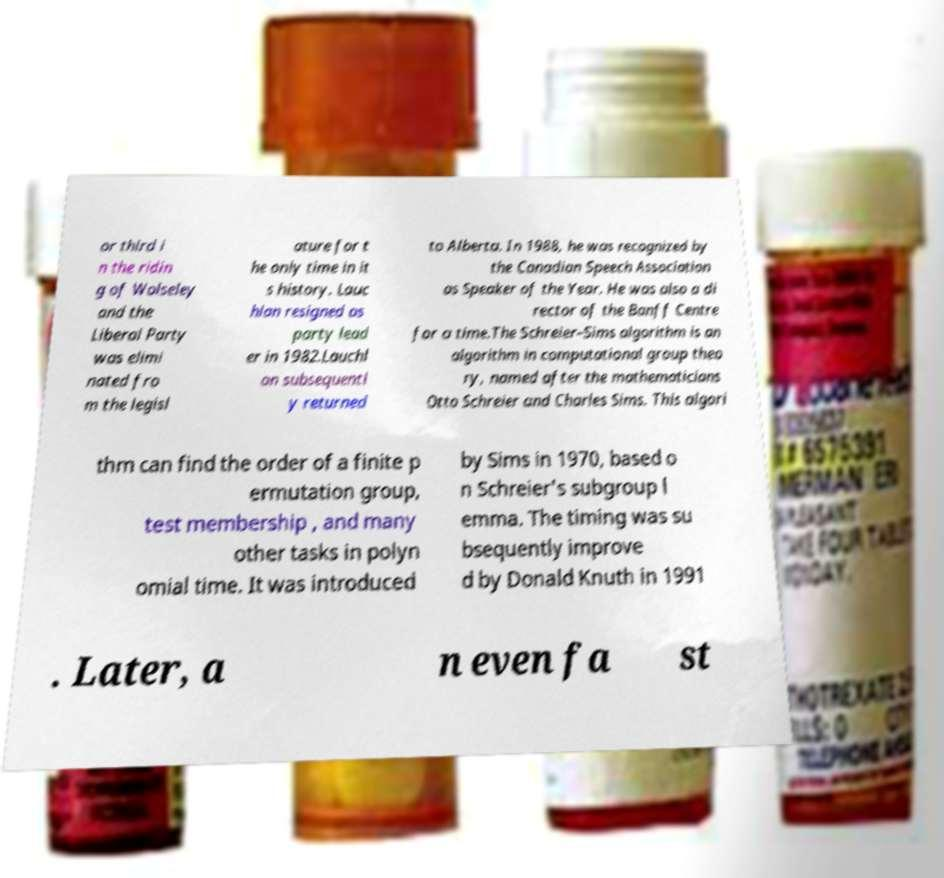Please identify and transcribe the text found in this image. or third i n the ridin g of Wolseley and the Liberal Party was elimi nated fro m the legisl ature for t he only time in it s history. Lauc hlan resigned as party lead er in 1982.Lauchl an subsequentl y returned to Alberta. In 1988, he was recognized by the Canadian Speech Association as Speaker of the Year. He was also a di rector of the Banff Centre for a time.The Schreier–Sims algorithm is an algorithm in computational group theo ry, named after the mathematicians Otto Schreier and Charles Sims. This algori thm can find the order of a finite p ermutation group, test membership , and many other tasks in polyn omial time. It was introduced by Sims in 1970, based o n Schreier's subgroup l emma. The timing was su bsequently improve d by Donald Knuth in 1991 . Later, a n even fa st 